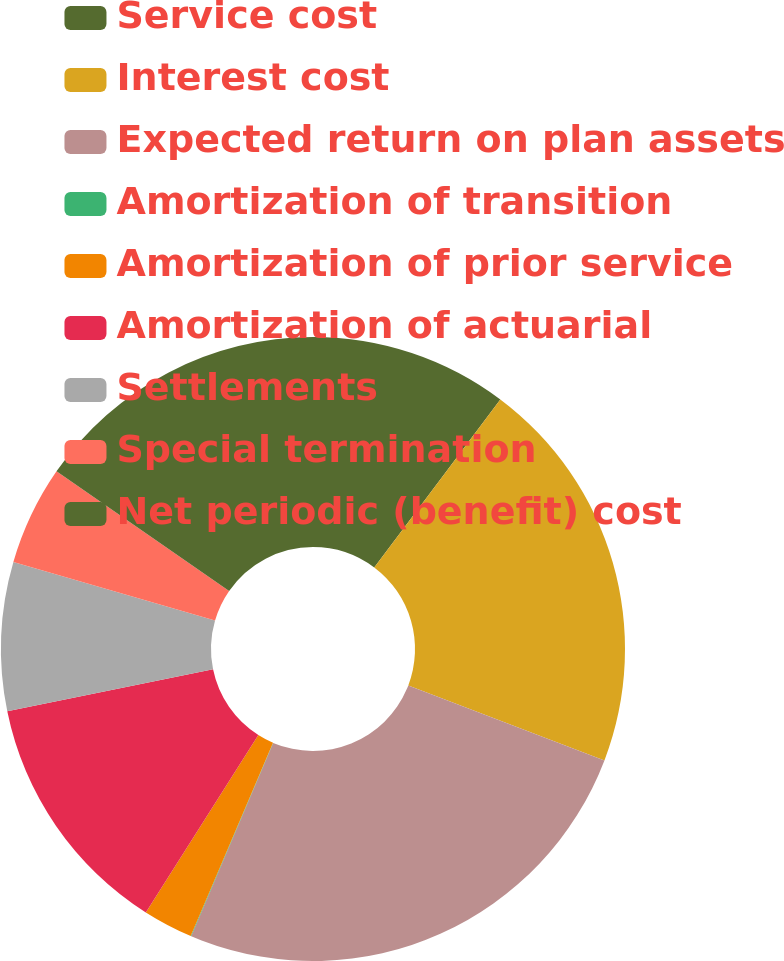Convert chart. <chart><loc_0><loc_0><loc_500><loc_500><pie_chart><fcel>Service cost<fcel>Interest cost<fcel>Expected return on plan assets<fcel>Amortization of transition<fcel>Amortization of prior service<fcel>Amortization of actuarial<fcel>Settlements<fcel>Special termination<fcel>Net periodic (benefit) cost<nl><fcel>10.25%<fcel>20.56%<fcel>25.57%<fcel>0.03%<fcel>2.59%<fcel>12.8%<fcel>7.7%<fcel>5.14%<fcel>15.36%<nl></chart> 